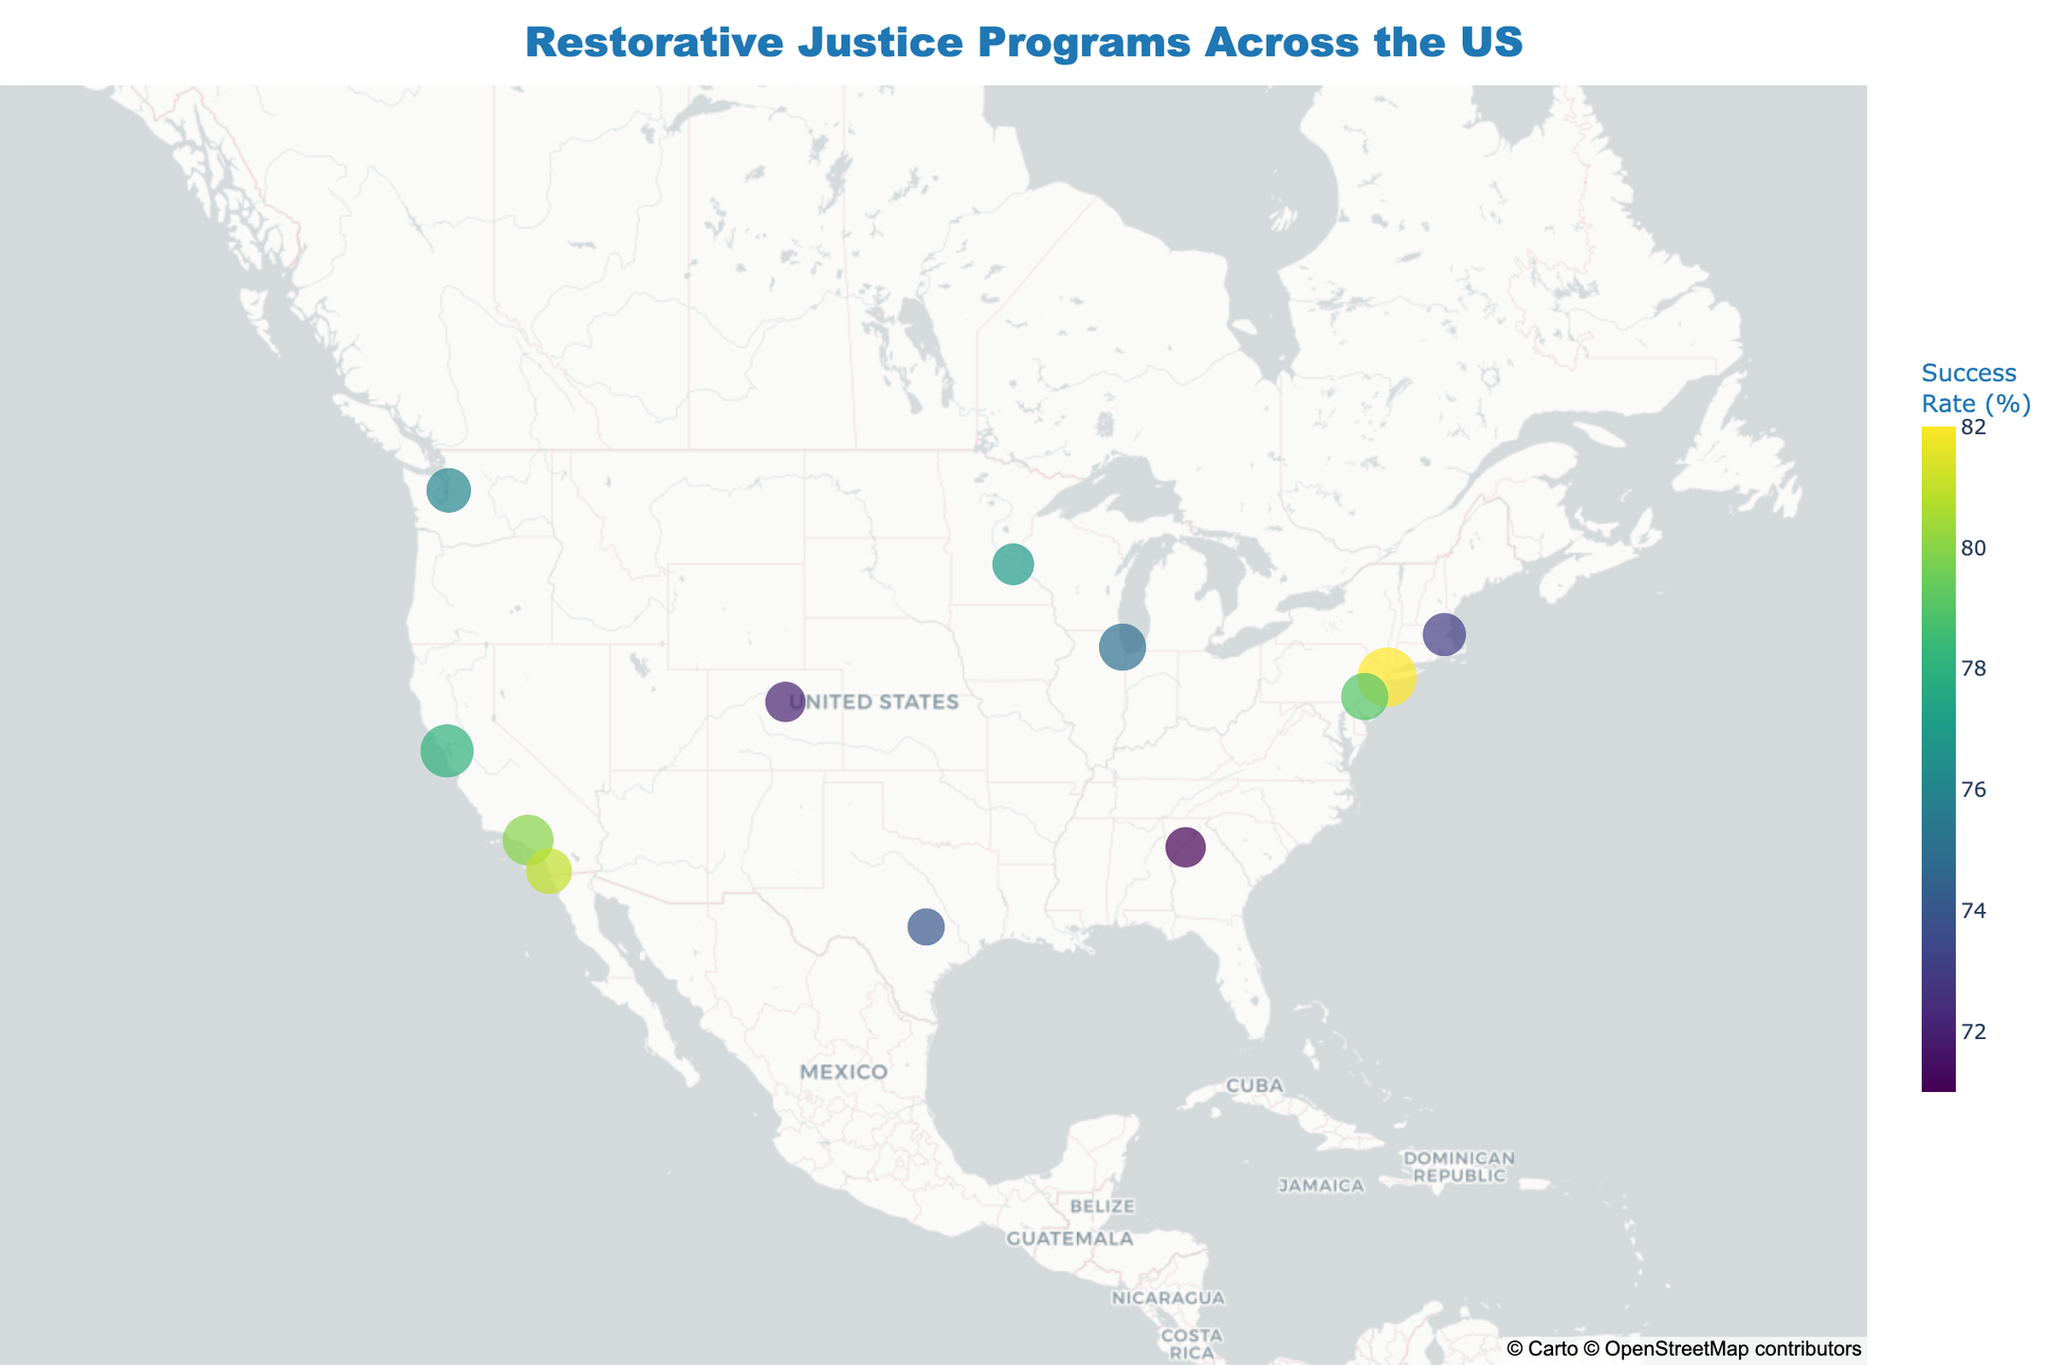What's the title of the figure? The title is displayed at the top center of the figure, highlighting the main theme.
Answer: Restorative Justice Programs Across the US What is the color scheme used in the figure? The color scheme is indicated by the color of the data points, ranging from one end of the scale to the other.
Answer: Viridis Which organization has the highest outreach? By comparing the size of the data points, the largest one corresponds to the organization with the highest outreach.
Answer: New York Peace Institute Which organization has the lowest success rate? The color bar on the side represents success rates. The organization with the darkest color indicates the lowest success rate.
Answer: Atlanta Restorative Justice Center How many organizations have a success rate above 80%? Look for data points with colors indicating success rates above 80% according to the color bar.
Answer: 3 organizations Which two organizations are closest in location? Evaluate the geographic positions of the data points on the map, identifying the closest pair.
Answer: San Francisco Restorative Justice Project and San Diego Restorative Justice Mediation Program What is the average outreach of all organizations? Sum all outreach values and divide by the number of organizations (1200 + 1500 + 950 + 1100 + 800 + 700 + 850 + 950 + 600 + 750 + 700 + 900 = 12000, 12000 / 12)
Answer: 1000 Which region has the highest concentration of restorative justice programs? Identify the cluster of data points in a specific area on the map.
Answer: West Coast (California) Is there any correlation between outreach and success rate based on the figure? Analyze the sizes and colors of the data points to see if larger points (high outreach) tend to be more colorful (high success rate).
Answer: Not clearly visible without further analysis 